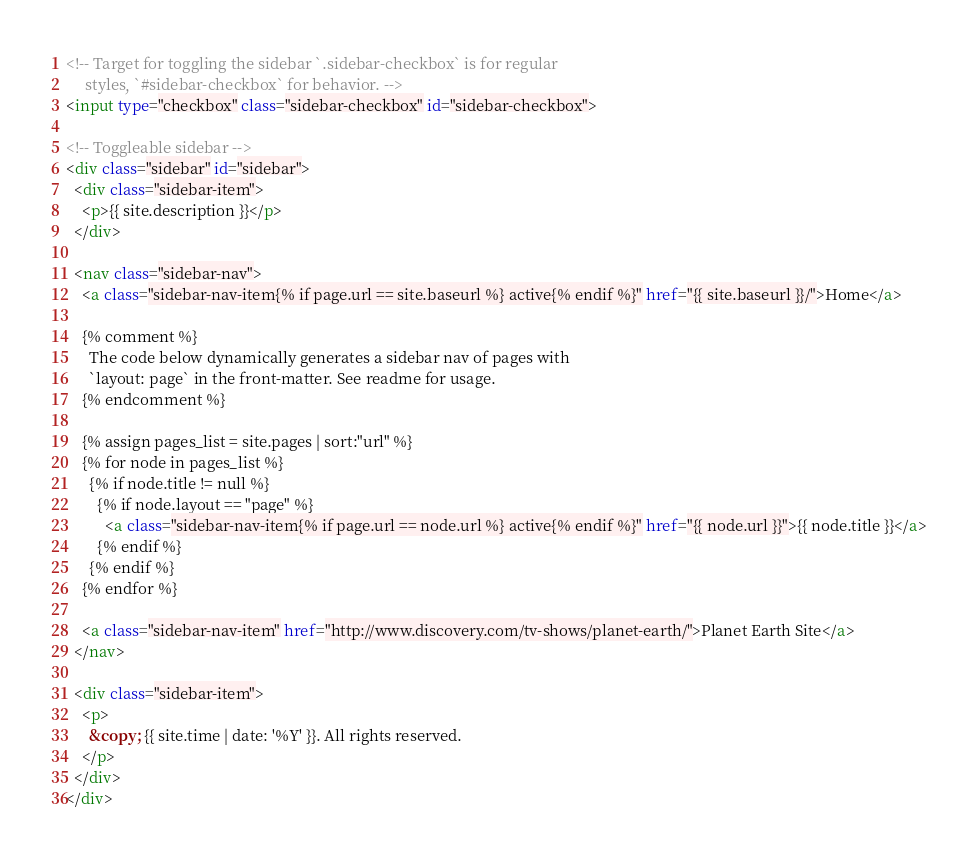<code> <loc_0><loc_0><loc_500><loc_500><_HTML_><!-- Target for toggling the sidebar `.sidebar-checkbox` is for regular
     styles, `#sidebar-checkbox` for behavior. -->
<input type="checkbox" class="sidebar-checkbox" id="sidebar-checkbox">

<!-- Toggleable sidebar -->
<div class="sidebar" id="sidebar">
  <div class="sidebar-item">
    <p>{{ site.description }}</p>
  </div>

  <nav class="sidebar-nav">
    <a class="sidebar-nav-item{% if page.url == site.baseurl %} active{% endif %}" href="{{ site.baseurl }}/">Home</a>

    {% comment %}
      The code below dynamically generates a sidebar nav of pages with
      `layout: page` in the front-matter. See readme for usage.
    {% endcomment %}

    {% assign pages_list = site.pages | sort:"url" %}
    {% for node in pages_list %}
      {% if node.title != null %}
        {% if node.layout == "page" %}
          <a class="sidebar-nav-item{% if page.url == node.url %} active{% endif %}" href="{{ node.url }}">{{ node.title }}</a>
        {% endif %}
      {% endif %}
    {% endfor %}

    <a class="sidebar-nav-item" href="http://www.discovery.com/tv-shows/planet-earth/">Planet Earth Site</a>
  </nav>

  <div class="sidebar-item">
    <p>
      &copy; {{ site.time | date: '%Y' }}. All rights reserved.
    </p>
  </div>
</div>
</code> 